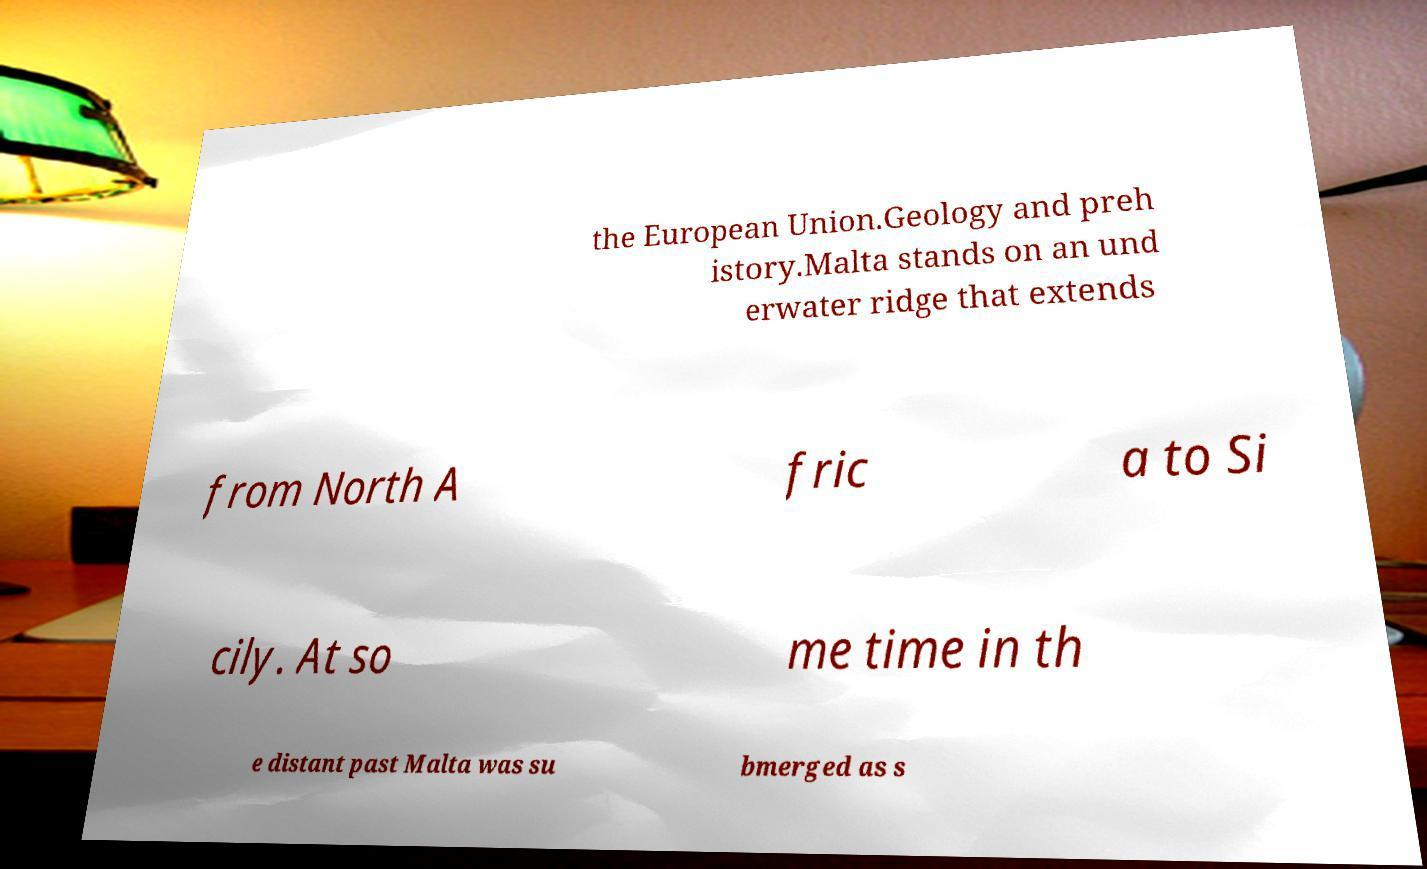There's text embedded in this image that I need extracted. Can you transcribe it verbatim? the European Union.Geology and preh istory.Malta stands on an und erwater ridge that extends from North A fric a to Si cily. At so me time in th e distant past Malta was su bmerged as s 